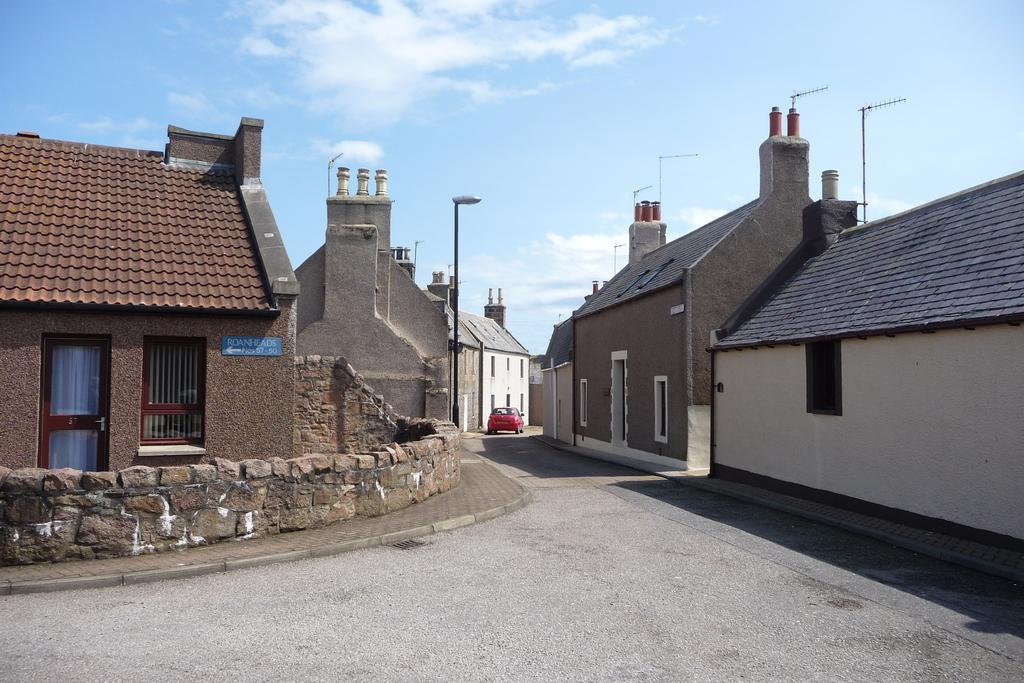What type of structures are visible in the image? There is a group of houses in the image. What can be seen in the middle of the image? There is a car in the middle of the image. What is attached to the street pole in the middle of the image? There is a light on the street pole in the middle of the image. What is visible at the top of the image? The sky is clear and visible at the top of the image. How many feet are visible on the houses in the image? There are no feet visible on the houses in the image. What type of relationship does the car have with the group of houses in the image? The car is simply located in the middle of the image and does not have a specific relationship with the group of houses. 